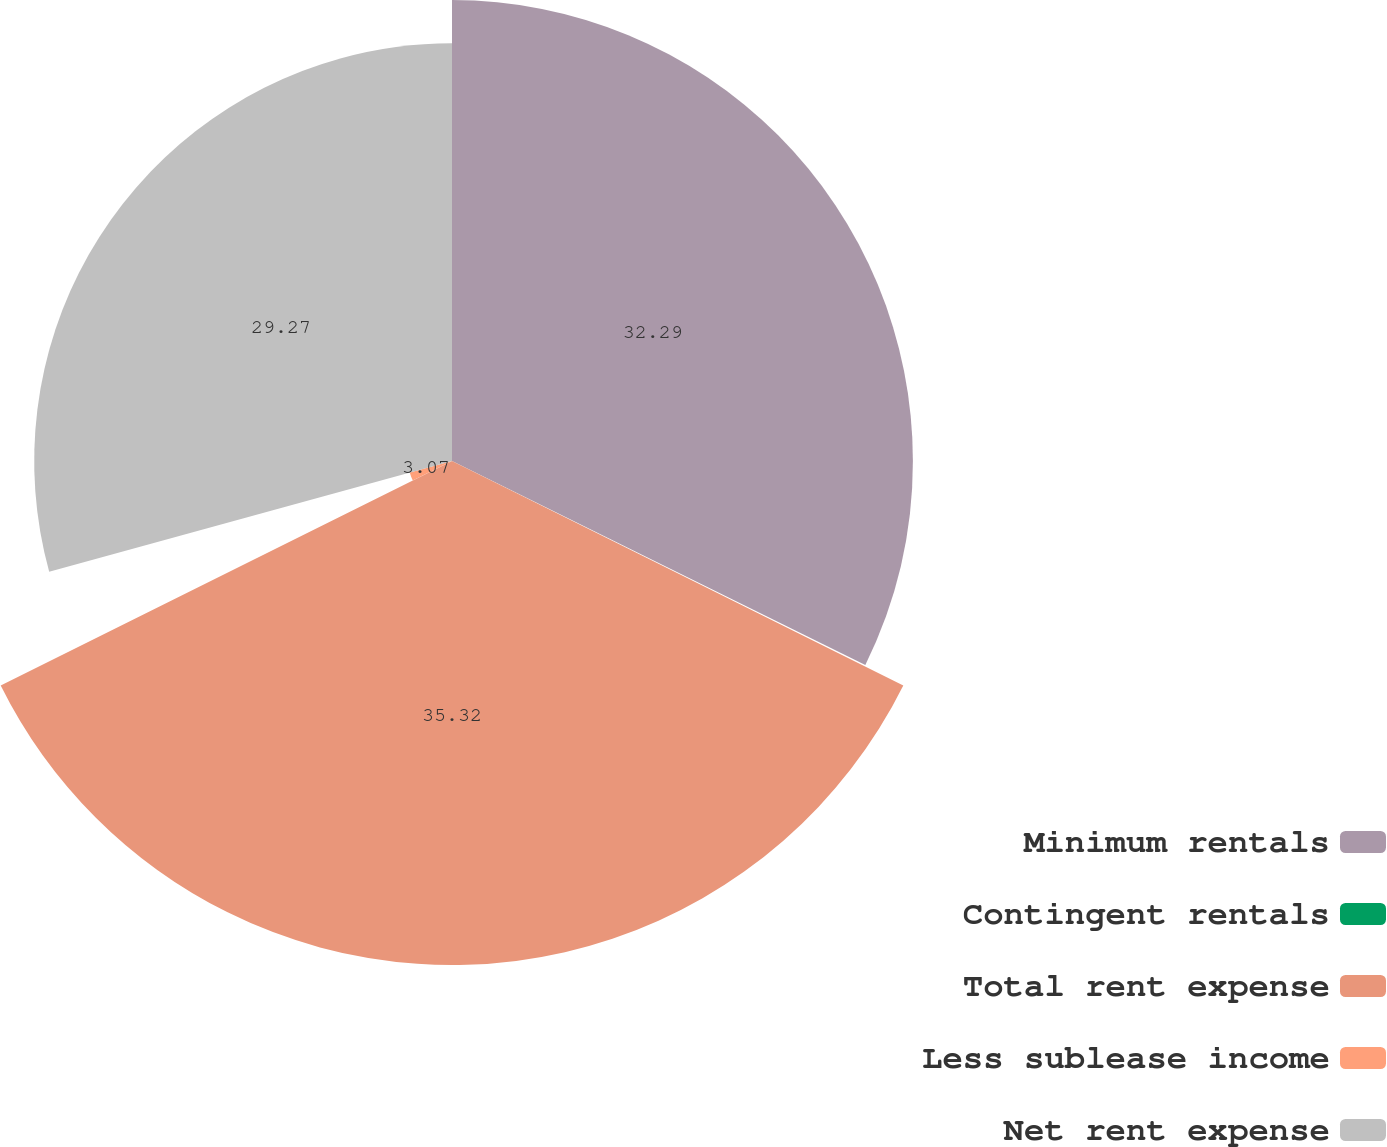Convert chart. <chart><loc_0><loc_0><loc_500><loc_500><pie_chart><fcel>Minimum rentals<fcel>Contingent rentals<fcel>Total rent expense<fcel>Less sublease income<fcel>Net rent expense<nl><fcel>32.29%<fcel>0.05%<fcel>35.31%<fcel>3.07%<fcel>29.27%<nl></chart> 